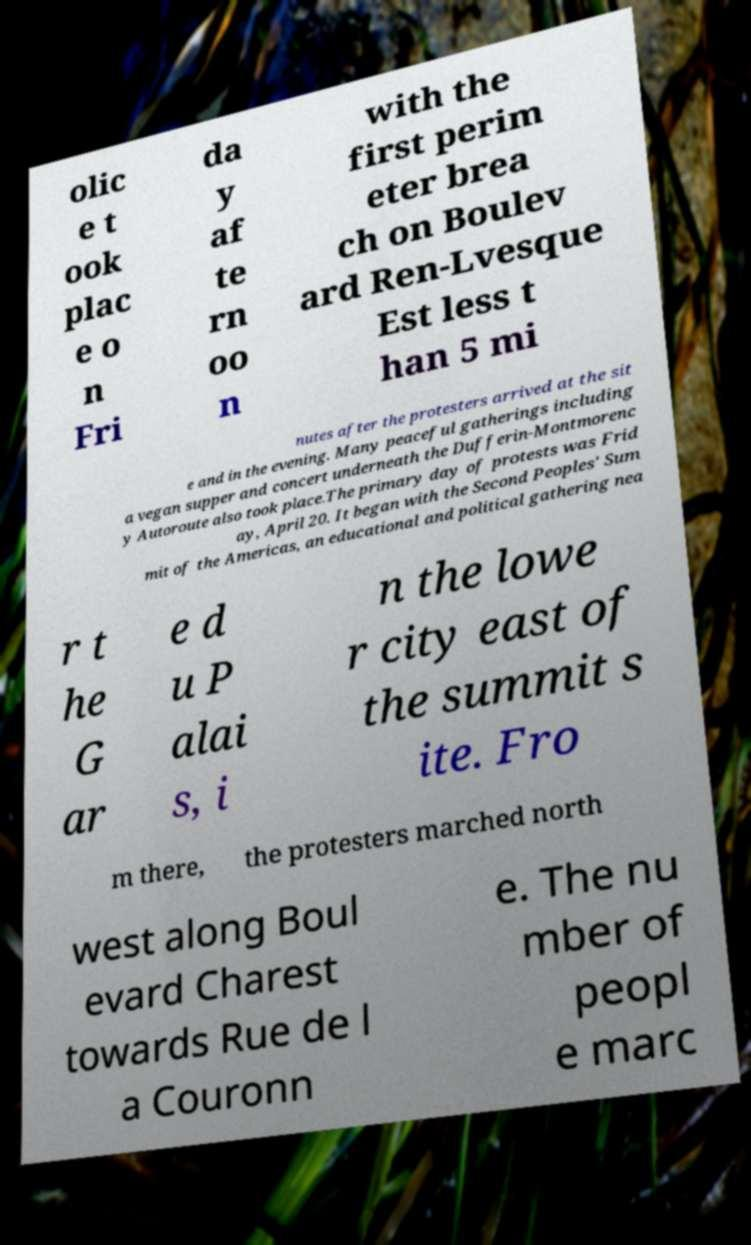Please read and relay the text visible in this image. What does it say? olic e t ook plac e o n Fri da y af te rn oo n with the first perim eter brea ch on Boulev ard Ren-Lvesque Est less t han 5 mi nutes after the protesters arrived at the sit e and in the evening. Many peaceful gatherings including a vegan supper and concert underneath the Dufferin-Montmorenc y Autoroute also took place.The primary day of protests was Frid ay, April 20. It began with the Second Peoples' Sum mit of the Americas, an educational and political gathering nea r t he G ar e d u P alai s, i n the lowe r city east of the summit s ite. Fro m there, the protesters marched north west along Boul evard Charest towards Rue de l a Couronn e. The nu mber of peopl e marc 